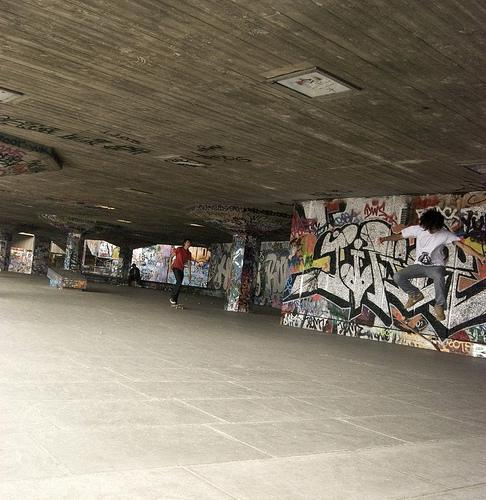How many instances of graffiti can you count in the image? There are at least 10 instances of graffiti in the image. What is the primary activity taking place in this image? A person is skateboarding in a graffiti-covered area. Identify and describe the type of area where the skateboarder is performing. It's an open-air covered area with gray cement pavers and graffiti-covered surfaces, used for skateboarding. What is the color of the skateboarder's shirt and how many people are skateboarding in the image? The skateboarder's shirt is red, and there is one skateboarder in the image. Explain the relationship between the skateboarder and the environment. The skateboarder is actively engaging with the graffiti-covered environment, showcasing their skills and embracing the urban culture. Identify a unique object or aspect of the image and provide a brief description. A heart-shaped graffiti is painted on a wall, adding a touch of emotion and individual expression to the image. List three different objects you can find in the image. Skateboarder, graffiti on walls, overhead light. Rate the overall quality of the image on a scale of 1 to 5. 4 (based on the amount of details and clear description) What is the general mood or emotion conveyed by the image? The image conveys a sense of excitement, adventure, and creativity. Mention any two prominent colors in the graffiti and an object interacting with it. Red and blue are prominent colors in the graffiti, while a skateboard rider interacts with the graffiti-covered surroundings. Did you notice the dog chasing after the skateboarder? A dog has not been detected in the list of objects, so this instruction will cause confusion and mislead the viewer as they search for a nonexistent dog. Observe the group of children playing near the skateboarder. There are no children mentioned in the list of objects in the image; this instruction will mislead the viewer into looking for a group of children that isn't present. Check out the artist working on the graffiti in the top-right corner. There is no mention of an artist or any person working on graffiti in the image; this instruction will cause the viewer to search for someone that doesn't exist in the image. The parked blue car serves as a nice contrast to the graffiti-covered walls. There is no mention of a blue car or any vehicle in the list of objects; hence, this instruction will mislead the viewer into looking for a car that doesn't exist in the image. Notice the pink teddy bear hanging from the rooftop? There is no mention of a pink teddy bear in the list of objects detected in the image; mentioning it will mislead the viewer. Can you spot the yellow fire hydrant near the graffiti wall? There is no information about a yellow fire hydrant in the detected objects, so this instruction will lead the viewer to search for something that doesn't exist in the image. 